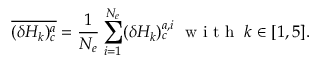Convert formula to latex. <formula><loc_0><loc_0><loc_500><loc_500>\overline { { ( \delta H _ { k } ) _ { c } ^ { a } } } = \frac { 1 } { N _ { e } } \sum _ { \substack { i = 1 } } ^ { N _ { e } } ( \delta H _ { k } ) _ { c } ^ { a , i } \, w i t h \, k \in [ 1 , 5 ] .</formula> 